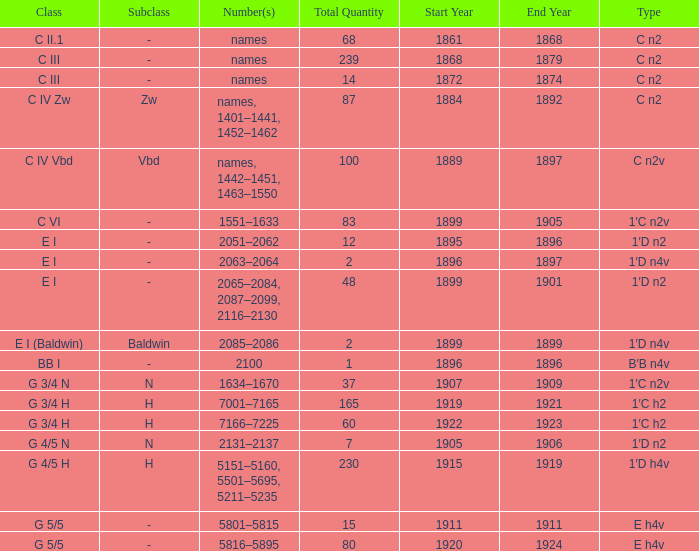Which Class has a Year(s) of Manufacture of 1899? E I (Baldwin). Would you mind parsing the complete table? {'header': ['Class', 'Subclass', 'Number(s)', 'Total Quantity', 'Start Year', 'End Year', 'Type'], 'rows': [['C II.1', '-', 'names', '68', '1861', '1868', 'C n2'], ['C III', '-', 'names', '239', '1868', '1879', 'C n2'], ['C III', '-', 'names', '14', '1872', '1874', 'C n2'], ['C IV Zw', 'Zw', 'names, 1401–1441, 1452–1462', '87', '1884', '1892', 'C n2'], ['C IV Vbd', 'Vbd', 'names, 1442–1451, 1463–1550', '100', '1889', '1897', 'C n2v'], ['C VI', '-', '1551–1633', '83', '1899', '1905', '1′C n2v'], ['E I', '-', '2051–2062', '12', '1895', '1896', '1′D n2'], ['E I', '-', '2063–2064', '2', '1896', '1897', '1′D n4v'], ['E I', '-', '2065–2084, 2087–2099, 2116–2130', '48', '1899', '1901', '1′D n2'], ['E I (Baldwin)', 'Baldwin', '2085–2086', '2', '1899', '1899', '1′D n4v'], ['BB I', '-', '2100', '1', '1896', '1896', 'B′B n4v'], ['G 3/4 N', 'N', '1634–1670', '37', '1907', '1909', '1′C n2v'], ['G 3/4 H', 'H', '7001–7165', '165', '1919', '1921', '1′C h2'], ['G 3/4 H', 'H', '7166–7225', '60', '1922', '1923', '1′C h2'], ['G 4/5 N', 'N', '2131–2137', '7', '1905', '1906', '1′D n2'], ['G 4/5 H', 'H', '5151–5160, 5501–5695, 5211–5235', '230', '1915', '1919', '1′D h4v'], ['G 5/5', '-', '5801–5815', '15', '1911', '1911', 'E h4v'], ['G 5/5', '-', '5816–5895', '80', '1920', '1924', 'E h4v']]} 